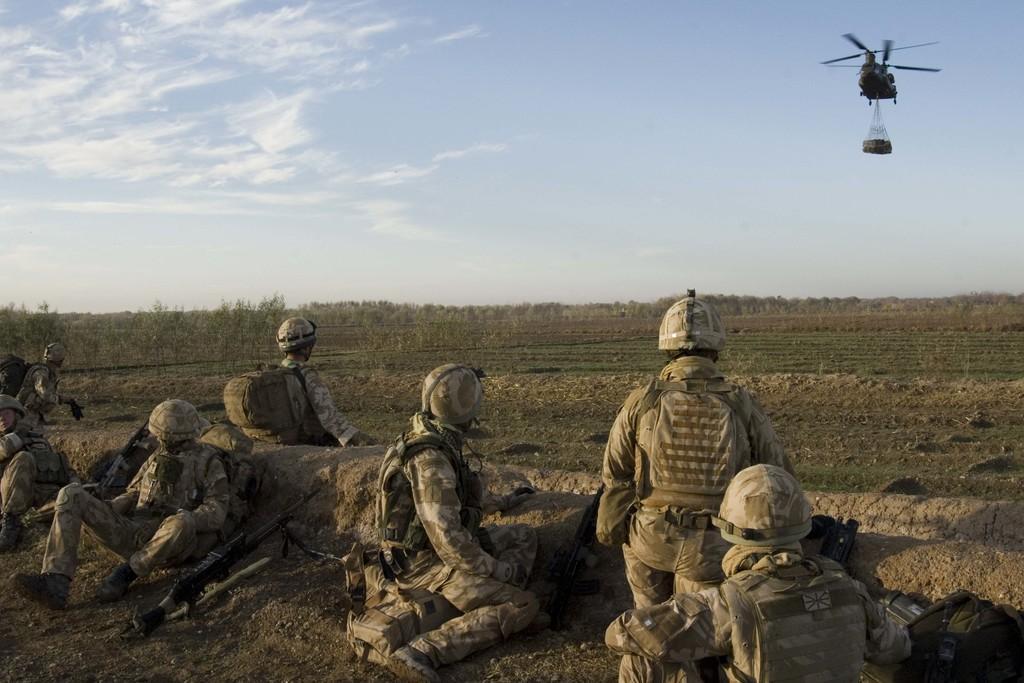How would you summarize this image in a sentence or two? In this image I can see few persons wearing uniforms are sitting on the ground and I can see a gun on the ground. In the background I can see few plants, an aircraft flying in the air and the sky. 